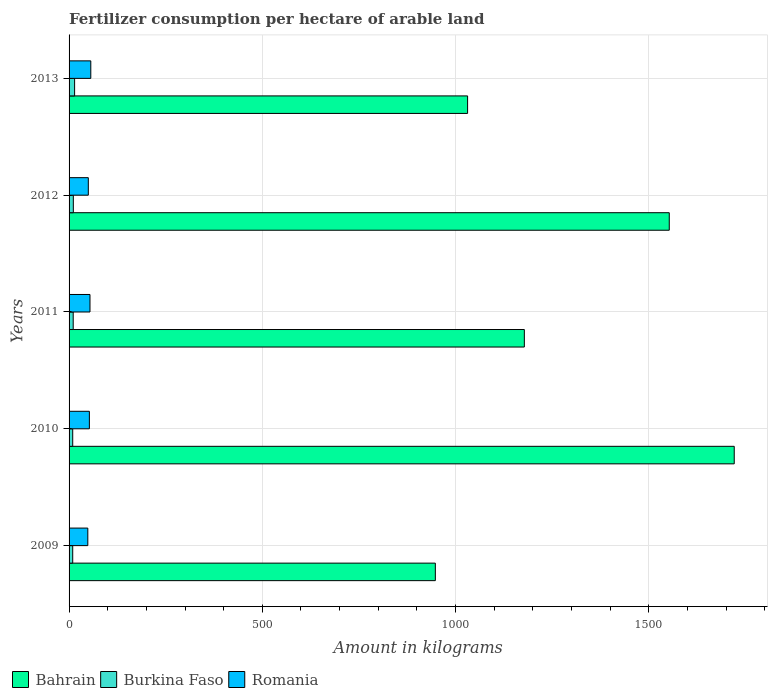Are the number of bars per tick equal to the number of legend labels?
Your answer should be compact. Yes. Are the number of bars on each tick of the Y-axis equal?
Your response must be concise. Yes. How many bars are there on the 3rd tick from the bottom?
Your response must be concise. 3. What is the amount of fertilizer consumption in Romania in 2011?
Your response must be concise. 54.13. Across all years, what is the maximum amount of fertilizer consumption in Romania?
Your answer should be very brief. 56.23. Across all years, what is the minimum amount of fertilizer consumption in Burkina Faso?
Your response must be concise. 9.43. In which year was the amount of fertilizer consumption in Burkina Faso maximum?
Offer a very short reply. 2013. In which year was the amount of fertilizer consumption in Burkina Faso minimum?
Provide a short and direct response. 2010. What is the total amount of fertilizer consumption in Romania in the graph?
Provide a short and direct response. 261.19. What is the difference between the amount of fertilizer consumption in Romania in 2011 and that in 2013?
Provide a short and direct response. -2.1. What is the difference between the amount of fertilizer consumption in Romania in 2009 and the amount of fertilizer consumption in Burkina Faso in 2012?
Provide a short and direct response. 37.5. What is the average amount of fertilizer consumption in Burkina Faso per year?
Provide a succinct answer. 10.98. In the year 2012, what is the difference between the amount of fertilizer consumption in Bahrain and amount of fertilizer consumption in Burkina Faso?
Ensure brevity in your answer.  1542.13. In how many years, is the amount of fertilizer consumption in Romania greater than 100 kg?
Provide a succinct answer. 0. What is the ratio of the amount of fertilizer consumption in Romania in 2011 to that in 2013?
Your response must be concise. 0.96. Is the amount of fertilizer consumption in Bahrain in 2010 less than that in 2011?
Your response must be concise. No. What is the difference between the highest and the second highest amount of fertilizer consumption in Romania?
Provide a short and direct response. 2.1. What is the difference between the highest and the lowest amount of fertilizer consumption in Romania?
Make the answer very short. 7.74. What does the 2nd bar from the top in 2013 represents?
Keep it short and to the point. Burkina Faso. What does the 1st bar from the bottom in 2010 represents?
Your response must be concise. Bahrain. Is it the case that in every year, the sum of the amount of fertilizer consumption in Burkina Faso and amount of fertilizer consumption in Bahrain is greater than the amount of fertilizer consumption in Romania?
Offer a terse response. Yes. How many bars are there?
Offer a terse response. 15. What is the difference between two consecutive major ticks on the X-axis?
Make the answer very short. 500. Does the graph contain grids?
Provide a short and direct response. Yes. How are the legend labels stacked?
Offer a very short reply. Horizontal. What is the title of the graph?
Provide a succinct answer. Fertilizer consumption per hectare of arable land. Does "United Arab Emirates" appear as one of the legend labels in the graph?
Provide a short and direct response. No. What is the label or title of the X-axis?
Provide a short and direct response. Amount in kilograms. What is the label or title of the Y-axis?
Offer a terse response. Years. What is the Amount in kilograms of Bahrain in 2009?
Your response must be concise. 947.79. What is the Amount in kilograms in Burkina Faso in 2009?
Make the answer very short. 9.45. What is the Amount in kilograms in Romania in 2009?
Your answer should be compact. 48.49. What is the Amount in kilograms in Bahrain in 2010?
Ensure brevity in your answer.  1721.25. What is the Amount in kilograms in Burkina Faso in 2010?
Keep it short and to the point. 9.43. What is the Amount in kilograms of Romania in 2010?
Keep it short and to the point. 52.55. What is the Amount in kilograms in Bahrain in 2011?
Your answer should be very brief. 1178.12. What is the Amount in kilograms in Burkina Faso in 2011?
Offer a terse response. 10.7. What is the Amount in kilograms in Romania in 2011?
Keep it short and to the point. 54.13. What is the Amount in kilograms in Bahrain in 2012?
Your answer should be compact. 1553.12. What is the Amount in kilograms of Burkina Faso in 2012?
Your answer should be compact. 11. What is the Amount in kilograms in Romania in 2012?
Your answer should be compact. 49.78. What is the Amount in kilograms of Bahrain in 2013?
Ensure brevity in your answer.  1031.25. What is the Amount in kilograms in Burkina Faso in 2013?
Offer a terse response. 14.32. What is the Amount in kilograms of Romania in 2013?
Give a very brief answer. 56.23. Across all years, what is the maximum Amount in kilograms of Bahrain?
Your response must be concise. 1721.25. Across all years, what is the maximum Amount in kilograms in Burkina Faso?
Your answer should be very brief. 14.32. Across all years, what is the maximum Amount in kilograms of Romania?
Ensure brevity in your answer.  56.23. Across all years, what is the minimum Amount in kilograms in Bahrain?
Your answer should be compact. 947.79. Across all years, what is the minimum Amount in kilograms of Burkina Faso?
Give a very brief answer. 9.43. Across all years, what is the minimum Amount in kilograms of Romania?
Give a very brief answer. 48.49. What is the total Amount in kilograms of Bahrain in the graph?
Give a very brief answer. 6431.54. What is the total Amount in kilograms of Burkina Faso in the graph?
Your answer should be compact. 54.9. What is the total Amount in kilograms in Romania in the graph?
Ensure brevity in your answer.  261.19. What is the difference between the Amount in kilograms in Bahrain in 2009 and that in 2010?
Provide a short and direct response. -773.46. What is the difference between the Amount in kilograms of Burkina Faso in 2009 and that in 2010?
Offer a very short reply. 0.02. What is the difference between the Amount in kilograms in Romania in 2009 and that in 2010?
Ensure brevity in your answer.  -4.05. What is the difference between the Amount in kilograms in Bahrain in 2009 and that in 2011?
Offer a very short reply. -230.33. What is the difference between the Amount in kilograms in Burkina Faso in 2009 and that in 2011?
Offer a very short reply. -1.25. What is the difference between the Amount in kilograms in Romania in 2009 and that in 2011?
Give a very brief answer. -5.64. What is the difference between the Amount in kilograms of Bahrain in 2009 and that in 2012?
Provide a short and direct response. -605.33. What is the difference between the Amount in kilograms in Burkina Faso in 2009 and that in 2012?
Offer a terse response. -1.55. What is the difference between the Amount in kilograms of Romania in 2009 and that in 2012?
Offer a very short reply. -1.29. What is the difference between the Amount in kilograms in Bahrain in 2009 and that in 2013?
Keep it short and to the point. -83.46. What is the difference between the Amount in kilograms of Burkina Faso in 2009 and that in 2013?
Offer a terse response. -4.87. What is the difference between the Amount in kilograms of Romania in 2009 and that in 2013?
Give a very brief answer. -7.74. What is the difference between the Amount in kilograms of Bahrain in 2010 and that in 2011?
Give a very brief answer. 543.12. What is the difference between the Amount in kilograms of Burkina Faso in 2010 and that in 2011?
Your answer should be compact. -1.27. What is the difference between the Amount in kilograms in Romania in 2010 and that in 2011?
Your answer should be very brief. -1.59. What is the difference between the Amount in kilograms in Bahrain in 2010 and that in 2012?
Ensure brevity in your answer.  168.12. What is the difference between the Amount in kilograms of Burkina Faso in 2010 and that in 2012?
Your response must be concise. -1.57. What is the difference between the Amount in kilograms of Romania in 2010 and that in 2012?
Make the answer very short. 2.77. What is the difference between the Amount in kilograms in Bahrain in 2010 and that in 2013?
Give a very brief answer. 690. What is the difference between the Amount in kilograms of Burkina Faso in 2010 and that in 2013?
Offer a very short reply. -4.89. What is the difference between the Amount in kilograms of Romania in 2010 and that in 2013?
Your response must be concise. -3.69. What is the difference between the Amount in kilograms of Bahrain in 2011 and that in 2012?
Make the answer very short. -375. What is the difference between the Amount in kilograms of Burkina Faso in 2011 and that in 2012?
Ensure brevity in your answer.  -0.3. What is the difference between the Amount in kilograms in Romania in 2011 and that in 2012?
Your answer should be very brief. 4.35. What is the difference between the Amount in kilograms of Bahrain in 2011 and that in 2013?
Ensure brevity in your answer.  146.88. What is the difference between the Amount in kilograms of Burkina Faso in 2011 and that in 2013?
Ensure brevity in your answer.  -3.62. What is the difference between the Amount in kilograms of Bahrain in 2012 and that in 2013?
Provide a succinct answer. 521.88. What is the difference between the Amount in kilograms in Burkina Faso in 2012 and that in 2013?
Provide a short and direct response. -3.32. What is the difference between the Amount in kilograms of Romania in 2012 and that in 2013?
Ensure brevity in your answer.  -6.45. What is the difference between the Amount in kilograms of Bahrain in 2009 and the Amount in kilograms of Burkina Faso in 2010?
Ensure brevity in your answer.  938.37. What is the difference between the Amount in kilograms of Bahrain in 2009 and the Amount in kilograms of Romania in 2010?
Your answer should be compact. 895.25. What is the difference between the Amount in kilograms in Burkina Faso in 2009 and the Amount in kilograms in Romania in 2010?
Keep it short and to the point. -43.09. What is the difference between the Amount in kilograms of Bahrain in 2009 and the Amount in kilograms of Burkina Faso in 2011?
Your answer should be very brief. 937.09. What is the difference between the Amount in kilograms in Bahrain in 2009 and the Amount in kilograms in Romania in 2011?
Offer a terse response. 893.66. What is the difference between the Amount in kilograms in Burkina Faso in 2009 and the Amount in kilograms in Romania in 2011?
Make the answer very short. -44.68. What is the difference between the Amount in kilograms of Bahrain in 2009 and the Amount in kilograms of Burkina Faso in 2012?
Provide a short and direct response. 936.8. What is the difference between the Amount in kilograms in Bahrain in 2009 and the Amount in kilograms in Romania in 2012?
Provide a short and direct response. 898.01. What is the difference between the Amount in kilograms in Burkina Faso in 2009 and the Amount in kilograms in Romania in 2012?
Provide a succinct answer. -40.33. What is the difference between the Amount in kilograms of Bahrain in 2009 and the Amount in kilograms of Burkina Faso in 2013?
Ensure brevity in your answer.  933.48. What is the difference between the Amount in kilograms in Bahrain in 2009 and the Amount in kilograms in Romania in 2013?
Provide a succinct answer. 891.56. What is the difference between the Amount in kilograms in Burkina Faso in 2009 and the Amount in kilograms in Romania in 2013?
Ensure brevity in your answer.  -46.78. What is the difference between the Amount in kilograms of Bahrain in 2010 and the Amount in kilograms of Burkina Faso in 2011?
Your response must be concise. 1710.55. What is the difference between the Amount in kilograms in Bahrain in 2010 and the Amount in kilograms in Romania in 2011?
Your response must be concise. 1667.12. What is the difference between the Amount in kilograms of Burkina Faso in 2010 and the Amount in kilograms of Romania in 2011?
Provide a succinct answer. -44.71. What is the difference between the Amount in kilograms in Bahrain in 2010 and the Amount in kilograms in Burkina Faso in 2012?
Give a very brief answer. 1710.25. What is the difference between the Amount in kilograms in Bahrain in 2010 and the Amount in kilograms in Romania in 2012?
Your answer should be compact. 1671.47. What is the difference between the Amount in kilograms of Burkina Faso in 2010 and the Amount in kilograms of Romania in 2012?
Your answer should be very brief. -40.35. What is the difference between the Amount in kilograms in Bahrain in 2010 and the Amount in kilograms in Burkina Faso in 2013?
Your answer should be very brief. 1706.93. What is the difference between the Amount in kilograms in Bahrain in 2010 and the Amount in kilograms in Romania in 2013?
Keep it short and to the point. 1665.02. What is the difference between the Amount in kilograms in Burkina Faso in 2010 and the Amount in kilograms in Romania in 2013?
Your response must be concise. -46.81. What is the difference between the Amount in kilograms of Bahrain in 2011 and the Amount in kilograms of Burkina Faso in 2012?
Keep it short and to the point. 1167.13. What is the difference between the Amount in kilograms in Bahrain in 2011 and the Amount in kilograms in Romania in 2012?
Offer a very short reply. 1128.34. What is the difference between the Amount in kilograms in Burkina Faso in 2011 and the Amount in kilograms in Romania in 2012?
Provide a succinct answer. -39.08. What is the difference between the Amount in kilograms of Bahrain in 2011 and the Amount in kilograms of Burkina Faso in 2013?
Your answer should be compact. 1163.81. What is the difference between the Amount in kilograms of Bahrain in 2011 and the Amount in kilograms of Romania in 2013?
Ensure brevity in your answer.  1121.89. What is the difference between the Amount in kilograms in Burkina Faso in 2011 and the Amount in kilograms in Romania in 2013?
Provide a succinct answer. -45.53. What is the difference between the Amount in kilograms of Bahrain in 2012 and the Amount in kilograms of Burkina Faso in 2013?
Ensure brevity in your answer.  1538.81. What is the difference between the Amount in kilograms of Bahrain in 2012 and the Amount in kilograms of Romania in 2013?
Provide a short and direct response. 1496.89. What is the difference between the Amount in kilograms in Burkina Faso in 2012 and the Amount in kilograms in Romania in 2013?
Ensure brevity in your answer.  -45.24. What is the average Amount in kilograms in Bahrain per year?
Make the answer very short. 1286.31. What is the average Amount in kilograms of Burkina Faso per year?
Offer a very short reply. 10.98. What is the average Amount in kilograms of Romania per year?
Ensure brevity in your answer.  52.24. In the year 2009, what is the difference between the Amount in kilograms in Bahrain and Amount in kilograms in Burkina Faso?
Make the answer very short. 938.34. In the year 2009, what is the difference between the Amount in kilograms of Bahrain and Amount in kilograms of Romania?
Your answer should be compact. 899.3. In the year 2009, what is the difference between the Amount in kilograms of Burkina Faso and Amount in kilograms of Romania?
Your response must be concise. -39.04. In the year 2010, what is the difference between the Amount in kilograms of Bahrain and Amount in kilograms of Burkina Faso?
Give a very brief answer. 1711.82. In the year 2010, what is the difference between the Amount in kilograms in Bahrain and Amount in kilograms in Romania?
Keep it short and to the point. 1668.7. In the year 2010, what is the difference between the Amount in kilograms of Burkina Faso and Amount in kilograms of Romania?
Ensure brevity in your answer.  -43.12. In the year 2011, what is the difference between the Amount in kilograms in Bahrain and Amount in kilograms in Burkina Faso?
Provide a succinct answer. 1167.42. In the year 2011, what is the difference between the Amount in kilograms in Bahrain and Amount in kilograms in Romania?
Your answer should be compact. 1123.99. In the year 2011, what is the difference between the Amount in kilograms of Burkina Faso and Amount in kilograms of Romania?
Offer a very short reply. -43.43. In the year 2012, what is the difference between the Amount in kilograms of Bahrain and Amount in kilograms of Burkina Faso?
Make the answer very short. 1542.13. In the year 2012, what is the difference between the Amount in kilograms in Bahrain and Amount in kilograms in Romania?
Provide a short and direct response. 1503.34. In the year 2012, what is the difference between the Amount in kilograms of Burkina Faso and Amount in kilograms of Romania?
Provide a succinct answer. -38.78. In the year 2013, what is the difference between the Amount in kilograms in Bahrain and Amount in kilograms in Burkina Faso?
Keep it short and to the point. 1016.93. In the year 2013, what is the difference between the Amount in kilograms in Bahrain and Amount in kilograms in Romania?
Ensure brevity in your answer.  975.01. In the year 2013, what is the difference between the Amount in kilograms in Burkina Faso and Amount in kilograms in Romania?
Make the answer very short. -41.92. What is the ratio of the Amount in kilograms of Bahrain in 2009 to that in 2010?
Your response must be concise. 0.55. What is the ratio of the Amount in kilograms in Burkina Faso in 2009 to that in 2010?
Offer a terse response. 1. What is the ratio of the Amount in kilograms of Romania in 2009 to that in 2010?
Ensure brevity in your answer.  0.92. What is the ratio of the Amount in kilograms in Bahrain in 2009 to that in 2011?
Give a very brief answer. 0.8. What is the ratio of the Amount in kilograms in Burkina Faso in 2009 to that in 2011?
Ensure brevity in your answer.  0.88. What is the ratio of the Amount in kilograms of Romania in 2009 to that in 2011?
Your response must be concise. 0.9. What is the ratio of the Amount in kilograms of Bahrain in 2009 to that in 2012?
Provide a short and direct response. 0.61. What is the ratio of the Amount in kilograms of Burkina Faso in 2009 to that in 2012?
Your answer should be compact. 0.86. What is the ratio of the Amount in kilograms in Romania in 2009 to that in 2012?
Your answer should be very brief. 0.97. What is the ratio of the Amount in kilograms in Bahrain in 2009 to that in 2013?
Your answer should be very brief. 0.92. What is the ratio of the Amount in kilograms of Burkina Faso in 2009 to that in 2013?
Provide a short and direct response. 0.66. What is the ratio of the Amount in kilograms of Romania in 2009 to that in 2013?
Your answer should be compact. 0.86. What is the ratio of the Amount in kilograms of Bahrain in 2010 to that in 2011?
Keep it short and to the point. 1.46. What is the ratio of the Amount in kilograms of Burkina Faso in 2010 to that in 2011?
Your answer should be compact. 0.88. What is the ratio of the Amount in kilograms in Romania in 2010 to that in 2011?
Offer a terse response. 0.97. What is the ratio of the Amount in kilograms in Bahrain in 2010 to that in 2012?
Your response must be concise. 1.11. What is the ratio of the Amount in kilograms of Burkina Faso in 2010 to that in 2012?
Ensure brevity in your answer.  0.86. What is the ratio of the Amount in kilograms in Romania in 2010 to that in 2012?
Offer a very short reply. 1.06. What is the ratio of the Amount in kilograms of Bahrain in 2010 to that in 2013?
Provide a succinct answer. 1.67. What is the ratio of the Amount in kilograms in Burkina Faso in 2010 to that in 2013?
Keep it short and to the point. 0.66. What is the ratio of the Amount in kilograms of Romania in 2010 to that in 2013?
Offer a very short reply. 0.93. What is the ratio of the Amount in kilograms in Bahrain in 2011 to that in 2012?
Your answer should be very brief. 0.76. What is the ratio of the Amount in kilograms in Burkina Faso in 2011 to that in 2012?
Ensure brevity in your answer.  0.97. What is the ratio of the Amount in kilograms of Romania in 2011 to that in 2012?
Make the answer very short. 1.09. What is the ratio of the Amount in kilograms of Bahrain in 2011 to that in 2013?
Provide a succinct answer. 1.14. What is the ratio of the Amount in kilograms in Burkina Faso in 2011 to that in 2013?
Provide a short and direct response. 0.75. What is the ratio of the Amount in kilograms of Romania in 2011 to that in 2013?
Your response must be concise. 0.96. What is the ratio of the Amount in kilograms in Bahrain in 2012 to that in 2013?
Offer a terse response. 1.51. What is the ratio of the Amount in kilograms of Burkina Faso in 2012 to that in 2013?
Ensure brevity in your answer.  0.77. What is the ratio of the Amount in kilograms of Romania in 2012 to that in 2013?
Your response must be concise. 0.89. What is the difference between the highest and the second highest Amount in kilograms of Bahrain?
Make the answer very short. 168.12. What is the difference between the highest and the second highest Amount in kilograms of Burkina Faso?
Provide a short and direct response. 3.32. What is the difference between the highest and the second highest Amount in kilograms in Romania?
Offer a very short reply. 2.1. What is the difference between the highest and the lowest Amount in kilograms in Bahrain?
Ensure brevity in your answer.  773.46. What is the difference between the highest and the lowest Amount in kilograms of Burkina Faso?
Your answer should be compact. 4.89. What is the difference between the highest and the lowest Amount in kilograms of Romania?
Your response must be concise. 7.74. 